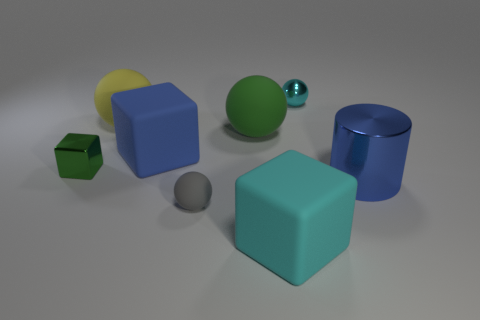Add 1 tiny gray cubes. How many objects exist? 9 Subtract all blue blocks. How many blocks are left? 2 Subtract all rubber spheres. How many spheres are left? 1 Subtract 2 spheres. How many spheres are left? 2 Subtract 0 red cylinders. How many objects are left? 8 Subtract all cylinders. How many objects are left? 7 Subtract all yellow spheres. Subtract all purple cubes. How many spheres are left? 3 Subtract all brown cylinders. How many cyan spheres are left? 1 Subtract all cyan rubber things. Subtract all large yellow spheres. How many objects are left? 6 Add 4 small metal balls. How many small metal balls are left? 5 